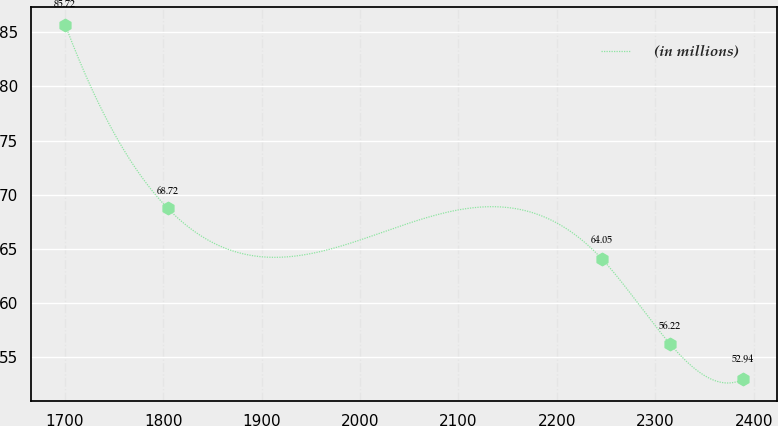Convert chart. <chart><loc_0><loc_0><loc_500><loc_500><line_chart><ecel><fcel>(in millions)<nl><fcel>1700.46<fcel>85.72<nl><fcel>1804.82<fcel>68.72<nl><fcel>2245.8<fcel>64.05<nl><fcel>2314.7<fcel>56.22<nl><fcel>2389.49<fcel>52.94<nl></chart> 